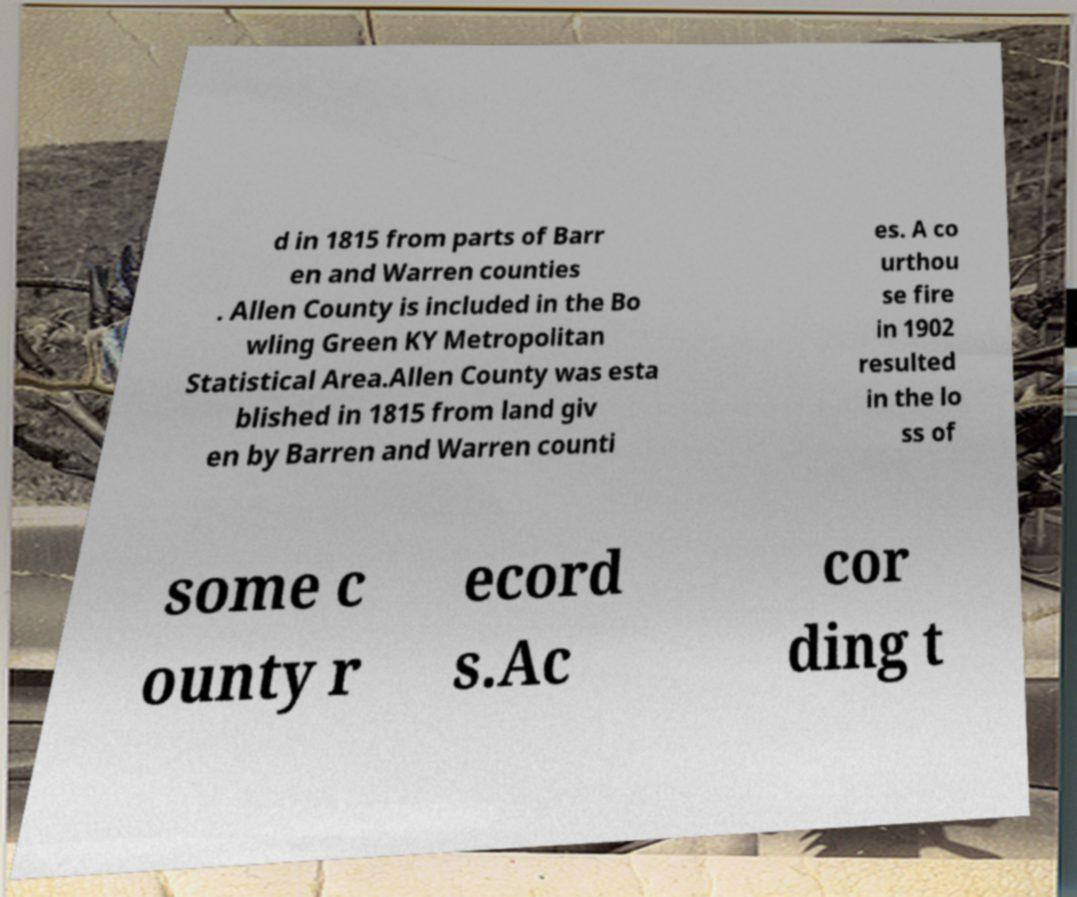There's text embedded in this image that I need extracted. Can you transcribe it verbatim? d in 1815 from parts of Barr en and Warren counties . Allen County is included in the Bo wling Green KY Metropolitan Statistical Area.Allen County was esta blished in 1815 from land giv en by Barren and Warren counti es. A co urthou se fire in 1902 resulted in the lo ss of some c ounty r ecord s.Ac cor ding t 